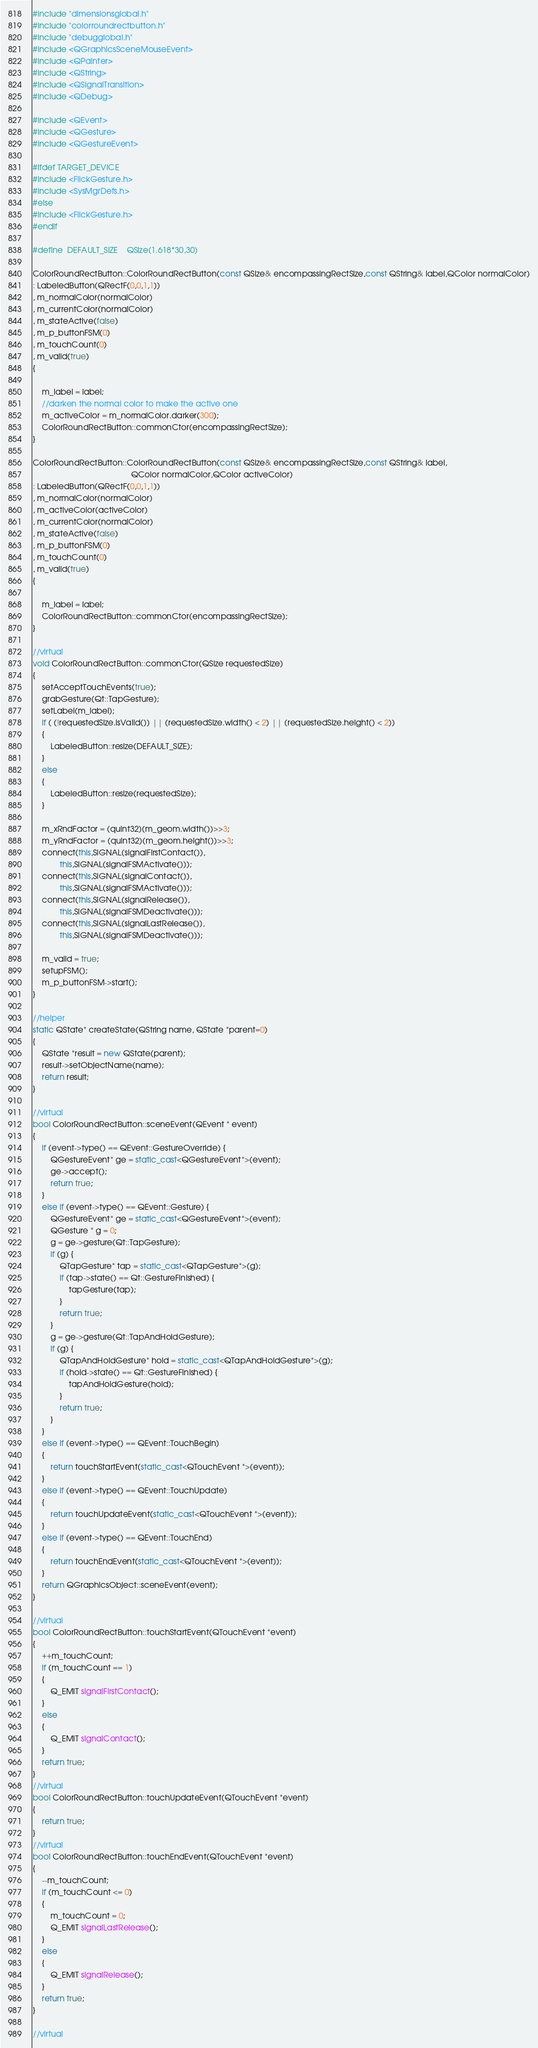<code> <loc_0><loc_0><loc_500><loc_500><_C++_>



#include "dimensionsglobal.h"
#include "colorroundrectbutton.h"
#include "debugglobal.h"
#include <QGraphicsSceneMouseEvent>
#include <QPainter>
#include <QString>
#include <QSignalTransition>
#include <QDebug>

#include <QEvent>
#include <QGesture>
#include <QGestureEvent>

#ifdef TARGET_DEVICE
#include <FlickGesture.h>
#include <SysMgrDefs.h>
#else
#include <FlickGesture.h>
#endif

#define	DEFAULT_SIZE	QSize(1.618*30,30)

ColorRoundRectButton::ColorRoundRectButton(const QSize& encompassingRectSize,const QString& label,QColor normalColor)
: LabeledButton(QRectF(0,0,1,1))
, m_normalColor(normalColor)
, m_currentColor(normalColor)
, m_stateActive(false)
, m_p_buttonFSM(0)
, m_touchCount(0)
, m_valid(true)
{

	m_label = label;
	//darken the normal color to make the active one
	m_activeColor = m_normalColor.darker(300);
	ColorRoundRectButton::commonCtor(encompassingRectSize);
}

ColorRoundRectButton::ColorRoundRectButton(const QSize& encompassingRectSize,const QString& label,
											QColor normalColor,QColor activeColor)
: LabeledButton(QRectF(0,0,1,1))
, m_normalColor(normalColor)
, m_activeColor(activeColor)
, m_currentColor(normalColor)
, m_stateActive(false)
, m_p_buttonFSM(0)
, m_touchCount(0)
, m_valid(true)
{

	m_label = label;
	ColorRoundRectButton::commonCtor(encompassingRectSize);
}

//virtual
void ColorRoundRectButton::commonCtor(QSize requestedSize)
{
	setAcceptTouchEvents(true);
	grabGesture(Qt::TapGesture);
	setLabel(m_label);
	if ( (!requestedSize.isValid()) || (requestedSize.width() < 2) || (requestedSize.height() < 2))
	{
		LabeledButton::resize(DEFAULT_SIZE);
	}
	else
	{
		LabeledButton::resize(requestedSize);
	}

	m_xRndFactor = (quint32)(m_geom.width())>>3;
	m_yRndFactor = (quint32)(m_geom.height())>>3;
	connect(this,SIGNAL(signalFirstContact()),
			this,SIGNAL(signalFSMActivate()));
	connect(this,SIGNAL(signalContact()),
			this,SIGNAL(signalFSMActivate()));
	connect(this,SIGNAL(signalRelease()),
			this,SIGNAL(signalFSMDeactivate()));
	connect(this,SIGNAL(signalLastRelease()),
			this,SIGNAL(signalFSMDeactivate()));

	m_valid = true;
	setupFSM();
	m_p_buttonFSM->start();
}

//helper
static QState* createState(QString name, QState *parent=0)
{
	QState *result = new QState(parent);
	result->setObjectName(name);
	return result;
}

//virtual
bool ColorRoundRectButton::sceneEvent(QEvent * event)
{
	if (event->type() == QEvent::GestureOverride) {
		QGestureEvent* ge = static_cast<QGestureEvent*>(event);
		ge->accept();
		return true;
	}
	else if (event->type() == QEvent::Gesture) {
		QGestureEvent* ge = static_cast<QGestureEvent*>(event);
		QGesture * g = 0;
		g = ge->gesture(Qt::TapGesture);
		if (g) {
			QTapGesture* tap = static_cast<QTapGesture*>(g);
			if (tap->state() == Qt::GestureFinished) {
				tapGesture(tap);
			}
			return true;
		}
		g = ge->gesture(Qt::TapAndHoldGesture);
		if (g) {
			QTapAndHoldGesture* hold = static_cast<QTapAndHoldGesture*>(g);
			if (hold->state() == Qt::GestureFinished) {
				tapAndHoldGesture(hold);
			}
			return true;
		}
	}
	else if (event->type() == QEvent::TouchBegin)
	{
		return touchStartEvent(static_cast<QTouchEvent *>(event));
	}
	else if (event->type() == QEvent::TouchUpdate)
	{
		return touchUpdateEvent(static_cast<QTouchEvent *>(event));
	}
	else if (event->type() == QEvent::TouchEnd)
	{
		return touchEndEvent(static_cast<QTouchEvent *>(event));
	}
	return QGraphicsObject::sceneEvent(event);
}

//virtual
bool ColorRoundRectButton::touchStartEvent(QTouchEvent *event)
{
	++m_touchCount;
	if (m_touchCount == 1)
	{
		Q_EMIT signalFirstContact();
	}
	else
	{
		Q_EMIT signalContact();
	}
	return true;
}
//virtual
bool ColorRoundRectButton::touchUpdateEvent(QTouchEvent *event)
{
	return true;
}
//virtual
bool ColorRoundRectButton::touchEndEvent(QTouchEvent *event)
{
	--m_touchCount;
	if (m_touchCount <= 0)
	{
		m_touchCount = 0;
		Q_EMIT signalLastRelease();
	}
	else
	{
		Q_EMIT signalRelease();
	}
	return true;
}

//virtual</code> 